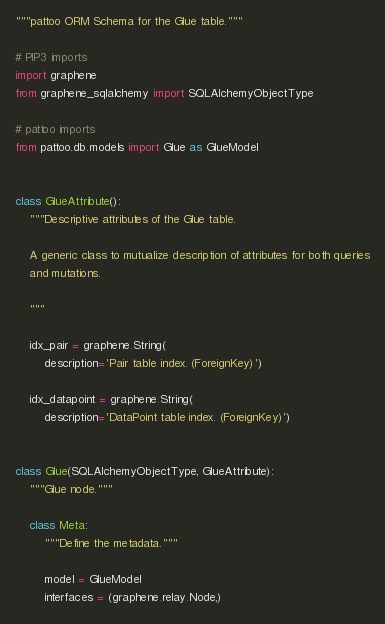<code> <loc_0><loc_0><loc_500><loc_500><_Python_>"""pattoo ORM Schema for the Glue table."""

# PIP3 imports
import graphene
from graphene_sqlalchemy import SQLAlchemyObjectType

# pattoo imports
from pattoo.db.models import Glue as GlueModel


class GlueAttribute():
    """Descriptive attributes of the Glue table.

    A generic class to mutualize description of attributes for both queries
    and mutations.

    """

    idx_pair = graphene.String(
        description='Pair table index. (ForeignKey)')

    idx_datapoint = graphene.String(
        description='DataPoint table index. (ForeignKey)')


class Glue(SQLAlchemyObjectType, GlueAttribute):
    """Glue node."""

    class Meta:
        """Define the metadata."""

        model = GlueModel
        interfaces = (graphene.relay.Node,)
</code> 